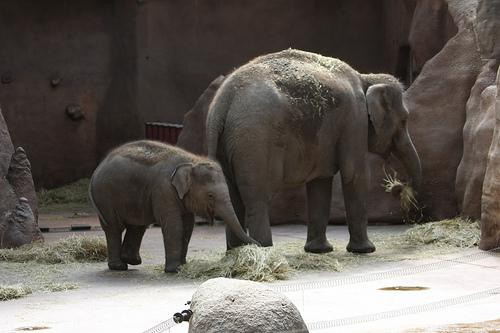Question: how many people are there?
Choices:
A. 1.
B. 2.
C. 0.
D. 3.
Answer with the letter. Answer: C Question: what is the elephant using to pick up its food?
Choices:
A. Its trunk.
B. A stick.
C. Its tusk.
D. Its mouth.
Answer with the letter. Answer: A Question: what are the elephants doing?
Choices:
A. Running.
B. Drinking.
C. Standing still.
D. Eating.
Answer with the letter. Answer: D Question: why are the elephants eating?
Choices:
A. It is their feeding time.
B. They are hungry.
C. They found food.
D. To keep other animals from getting the food.
Answer with the letter. Answer: B Question: how many legs does the smaller elephant have?
Choices:
A. 6.
B. 4.
C. 8.
D. 9.
Answer with the letter. Answer: B Question: how many elephant ears can be seen in the photo despite your knowledge of elephants?
Choices:
A. 3.
B. 2.
C. 4.
D. 5.
Answer with the letter. Answer: B 